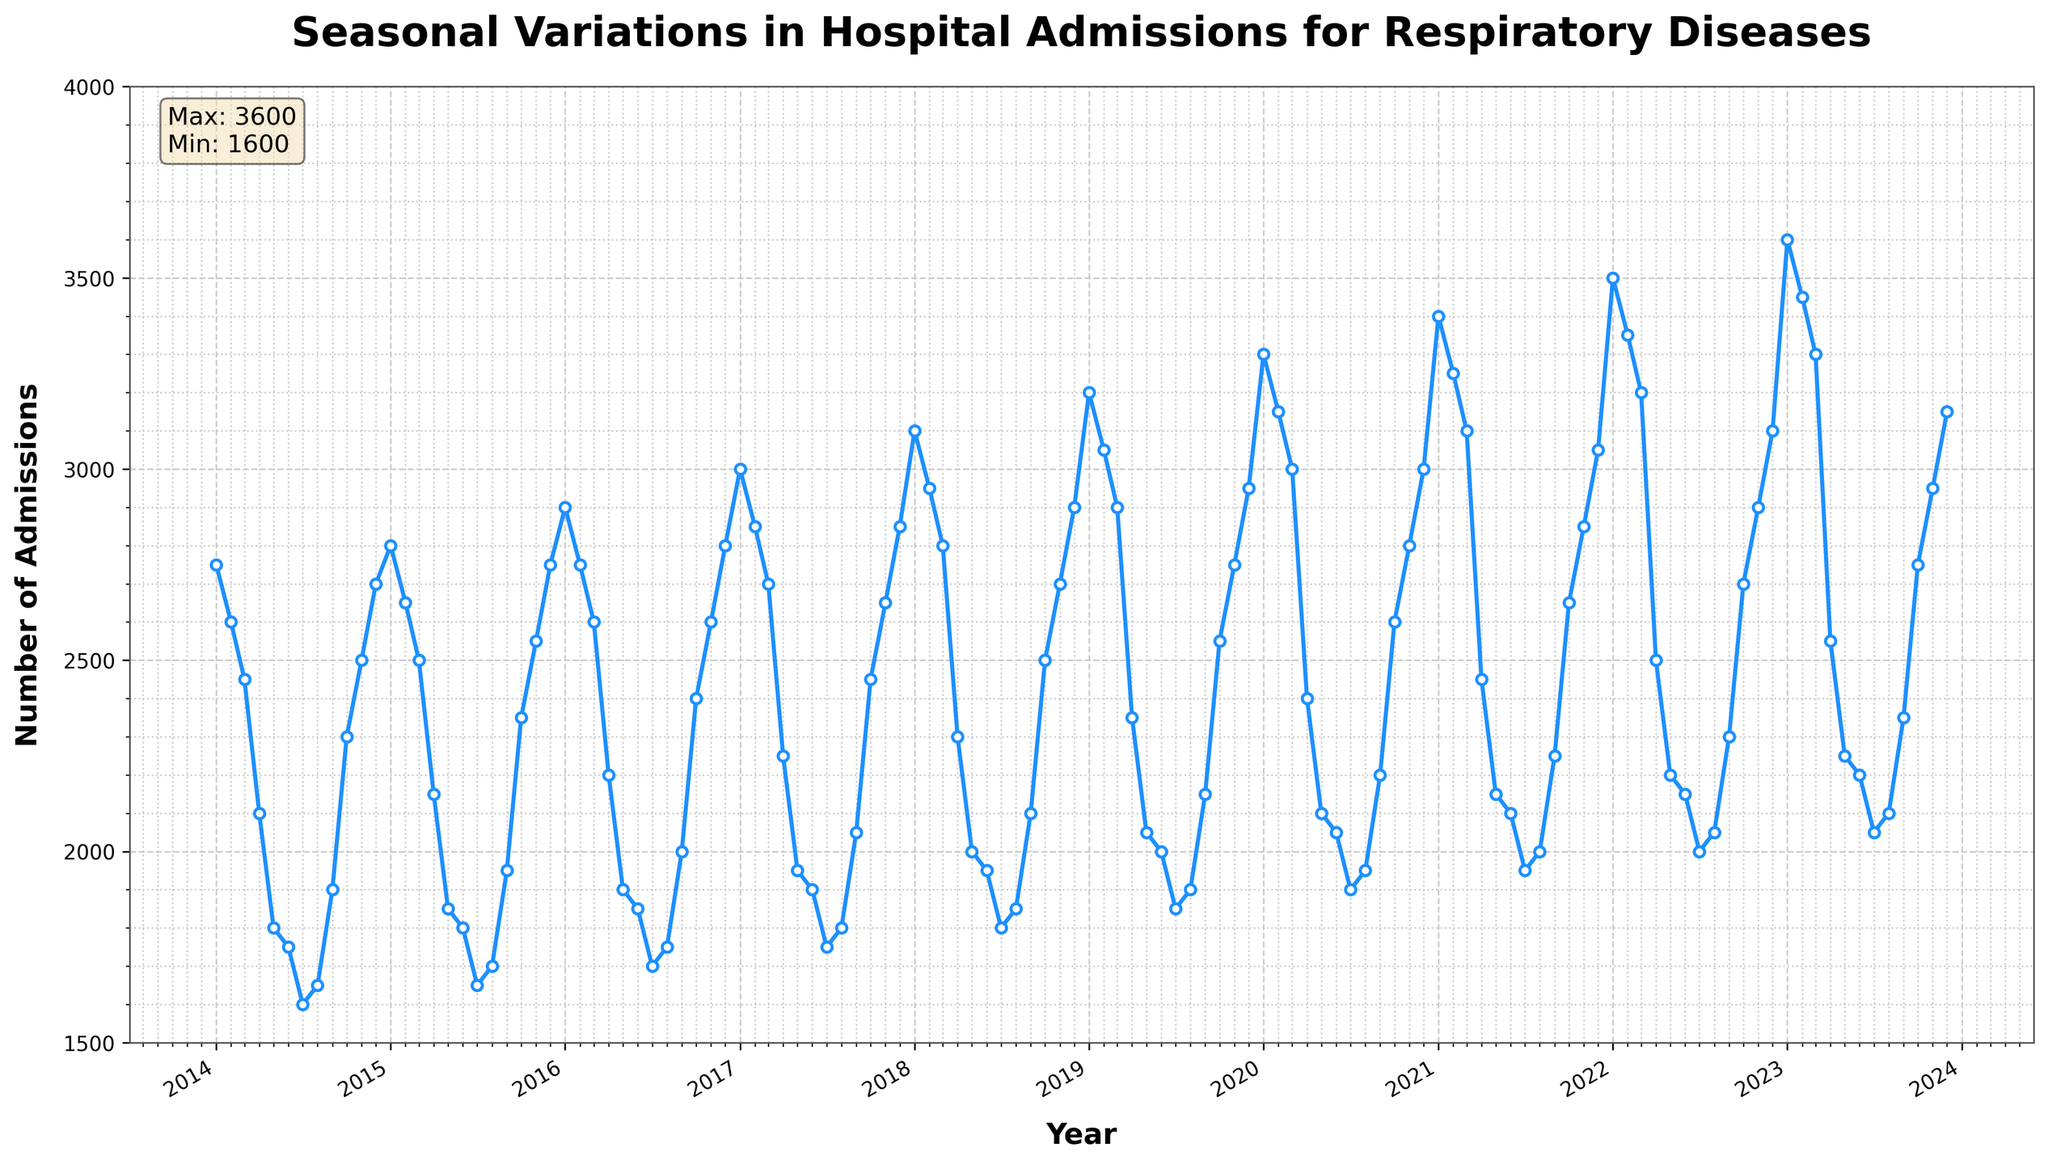What is the title of the plot? The title is usually displayed at the top of the plot and summarizes the content. In this case, it reads, "Seasonal Variations in Hospital Admissions for Respiratory Diseases".
Answer: Seasonal Variations in Hospital Admissions for Respiratory Diseases How are the admissions distributed throughout the year? By examining the plot, we can see that admissions tend to be higher during the colder months (December to February) and lower during the warmer months (June to August).
Answer: Higher in winter, lower in summer What is the highest number of admissions recorded? There is a text box in the plot that provides statistics including the maximum number of admissions, which is 3600.
Answer: 3600 What month and year had the highest number of admissions? Upon inspecting the curve, the highest peak occurs around January 2023.
Answer: January 2023 What is the trend of hospital admissions from 2014 to 2023? By observing the overall slope of the trend line in the plot, we see a general increase in the number of admissions over the decade.
Answer: Increasing trend What is the maximum difference in admissions between any two consecutive months? By scanning the plot and looking for the steepest rise or drop between any two points, we find that the difference between January and February 2022 is 150 (3500 to 3350).
Answer: 150 Compare the number of admissions in January 2015 and January 2020. Which one is higher? Inspect the plot at the data points for January in 2015 and 2020; it's clear that January 2020 had higher admissions.
Answer: January 2020 What month frequently shows the lowest number of admissions each year? By repeatedly checking each year's low points, it is evident that July consistently has the lowest admissions in most years.
Answer: July What is the average number of admissions in December over the decade? By summing the admissions for December from each year (2700 + 2750 + 2800 + 2850 + 2900 + 2950 + 3000 + 3050 + 3100 + 3150) and dividing by the 10 years, the average is 2925.
Answer: 2925 How does the number of admissions in December 2018 compare to December 2019? By comparing the data points for these months, December 2019 had 2950 admissions, while December 2018 had 2900 admissions. Thus, December 2019 had more admissions.
Answer: December 2019 had more 